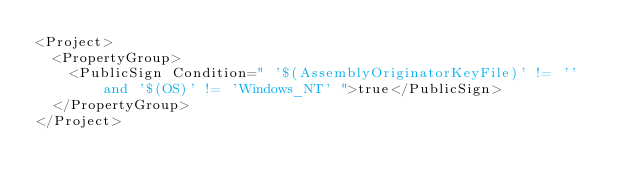<code> <loc_0><loc_0><loc_500><loc_500><_XML_><Project>
  <PropertyGroup>
    <PublicSign Condition=" '$(AssemblyOriginatorKeyFile)' != '' and '$(OS)' != 'Windows_NT' ">true</PublicSign>
  </PropertyGroup>
</Project>
</code> 